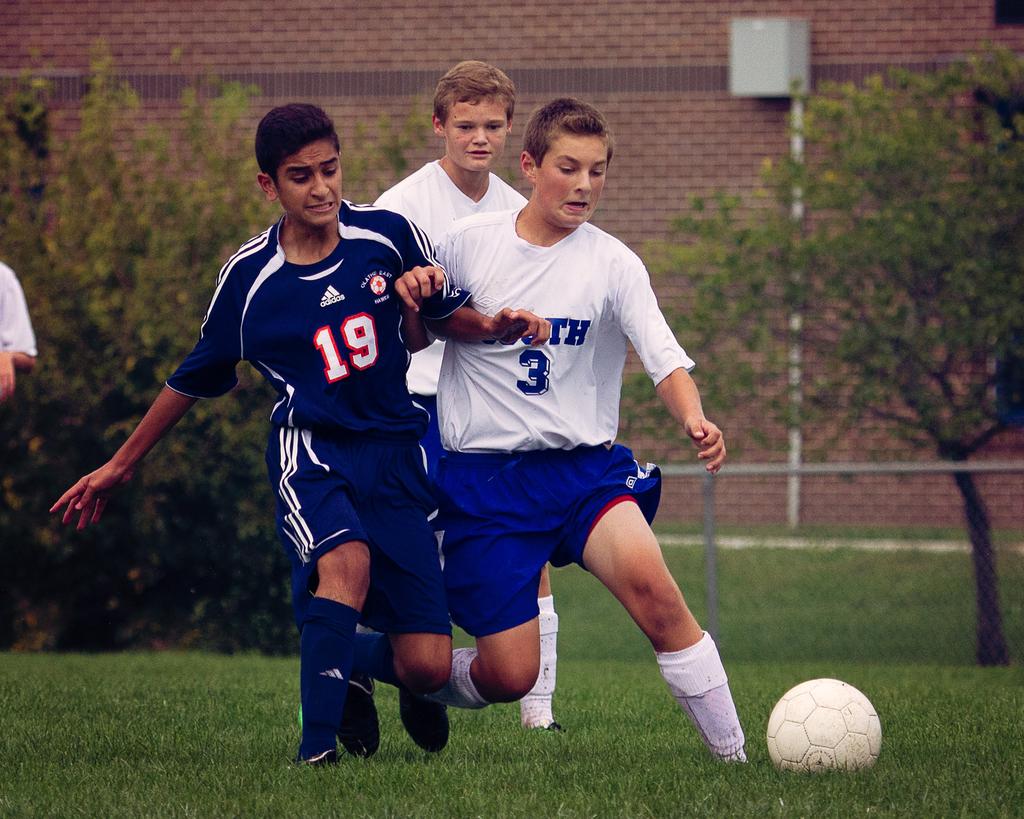What number is on the player with the white shirt?
Offer a very short reply. 3. 